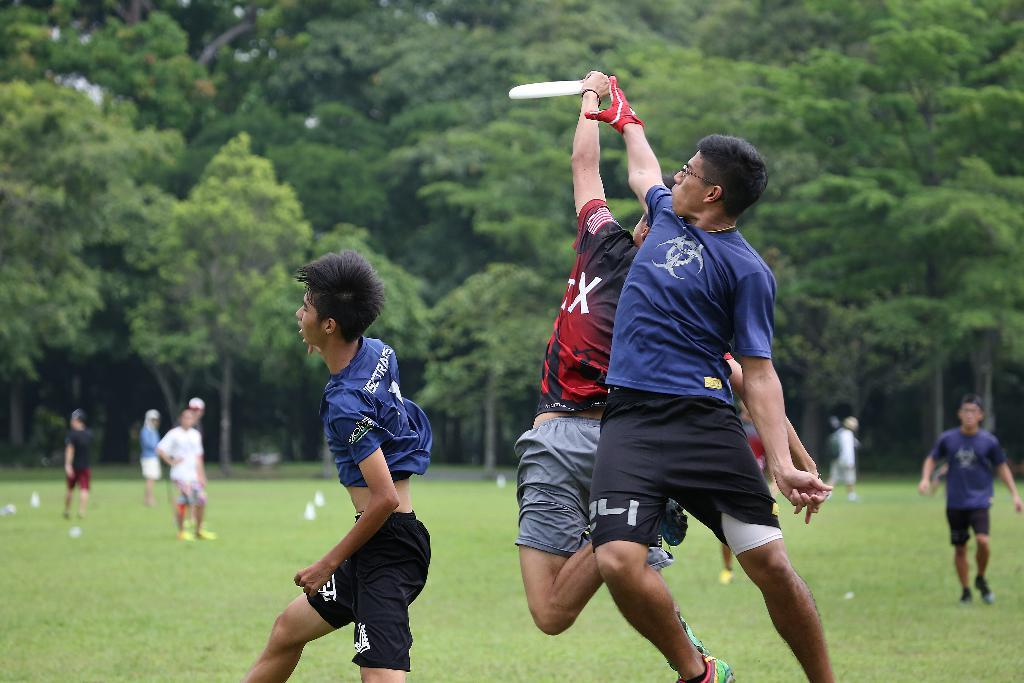<image>
Relay a brief, clear account of the picture shown. two players jump for a frisbee and the one player has an X on his shirt 